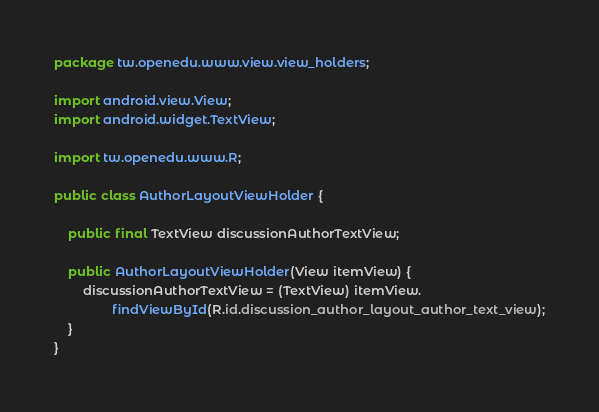<code> <loc_0><loc_0><loc_500><loc_500><_Java_>package tw.openedu.www.view.view_holders;

import android.view.View;
import android.widget.TextView;

import tw.openedu.www.R;

public class AuthorLayoutViewHolder {

    public final TextView discussionAuthorTextView;

    public AuthorLayoutViewHolder(View itemView) {
        discussionAuthorTextView = (TextView) itemView.
                findViewById(R.id.discussion_author_layout_author_text_view);
    }
}
</code> 